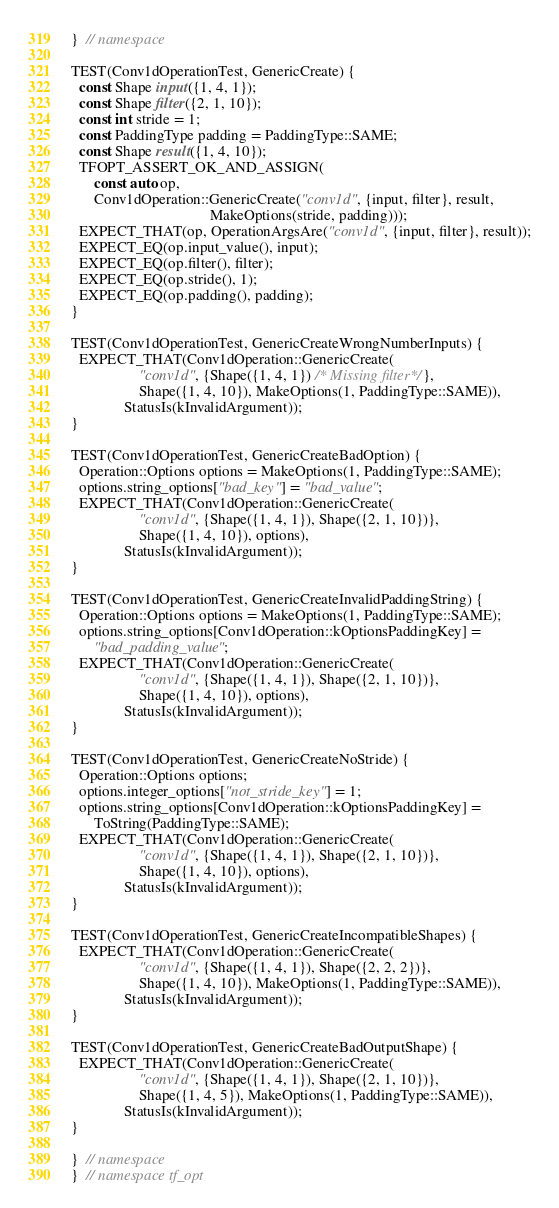Convert code to text. <code><loc_0><loc_0><loc_500><loc_500><_C++_>}  // namespace

TEST(Conv1dOperationTest, GenericCreate) {
  const Shape input({1, 4, 1});
  const Shape filter({2, 1, 10});
  const int stride = 1;
  const PaddingType padding = PaddingType::SAME;
  const Shape result({1, 4, 10});
  TFOPT_ASSERT_OK_AND_ASSIGN(
      const auto op,
      Conv1dOperation::GenericCreate("conv1d", {input, filter}, result,
                                     MakeOptions(stride, padding)));
  EXPECT_THAT(op, OperationArgsAre("conv1d", {input, filter}, result));
  EXPECT_EQ(op.input_value(), input);
  EXPECT_EQ(op.filter(), filter);
  EXPECT_EQ(op.stride(), 1);
  EXPECT_EQ(op.padding(), padding);
}

TEST(Conv1dOperationTest, GenericCreateWrongNumberInputs) {
  EXPECT_THAT(Conv1dOperation::GenericCreate(
                  "conv1d", {Shape({1, 4, 1}) /* Missing filter*/},
                  Shape({1, 4, 10}), MakeOptions(1, PaddingType::SAME)),
              StatusIs(kInvalidArgument));
}

TEST(Conv1dOperationTest, GenericCreateBadOption) {
  Operation::Options options = MakeOptions(1, PaddingType::SAME);
  options.string_options["bad_key"] = "bad_value";
  EXPECT_THAT(Conv1dOperation::GenericCreate(
                  "conv1d", {Shape({1, 4, 1}), Shape({2, 1, 10})},
                  Shape({1, 4, 10}), options),
              StatusIs(kInvalidArgument));
}

TEST(Conv1dOperationTest, GenericCreateInvalidPaddingString) {
  Operation::Options options = MakeOptions(1, PaddingType::SAME);
  options.string_options[Conv1dOperation::kOptionsPaddingKey] =
      "bad_padding_value";
  EXPECT_THAT(Conv1dOperation::GenericCreate(
                  "conv1d", {Shape({1, 4, 1}), Shape({2, 1, 10})},
                  Shape({1, 4, 10}), options),
              StatusIs(kInvalidArgument));
}

TEST(Conv1dOperationTest, GenericCreateNoStride) {
  Operation::Options options;
  options.integer_options["not_stride_key"] = 1;
  options.string_options[Conv1dOperation::kOptionsPaddingKey] =
      ToString(PaddingType::SAME);
  EXPECT_THAT(Conv1dOperation::GenericCreate(
                  "conv1d", {Shape({1, 4, 1}), Shape({2, 1, 10})},
                  Shape({1, 4, 10}), options),
              StatusIs(kInvalidArgument));
}

TEST(Conv1dOperationTest, GenericCreateIncompatibleShapes) {
  EXPECT_THAT(Conv1dOperation::GenericCreate(
                  "conv1d", {Shape({1, 4, 1}), Shape({2, 2, 2})},
                  Shape({1, 4, 10}), MakeOptions(1, PaddingType::SAME)),
              StatusIs(kInvalidArgument));
}

TEST(Conv1dOperationTest, GenericCreateBadOutputShape) {
  EXPECT_THAT(Conv1dOperation::GenericCreate(
                  "conv1d", {Shape({1, 4, 1}), Shape({2, 1, 10})},
                  Shape({1, 4, 5}), MakeOptions(1, PaddingType::SAME)),
              StatusIs(kInvalidArgument));
}

}  // namespace
}  // namespace tf_opt
</code> 